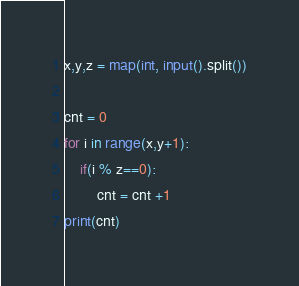Convert code to text. <code><loc_0><loc_0><loc_500><loc_500><_Python_>x,y,z = map(int, input().split())

cnt = 0
for i in range(x,y+1):
    if(i % z==0):
        cnt = cnt +1
print(cnt)
</code> 